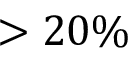Convert formula to latex. <formula><loc_0><loc_0><loc_500><loc_500>> 2 0 \%</formula> 